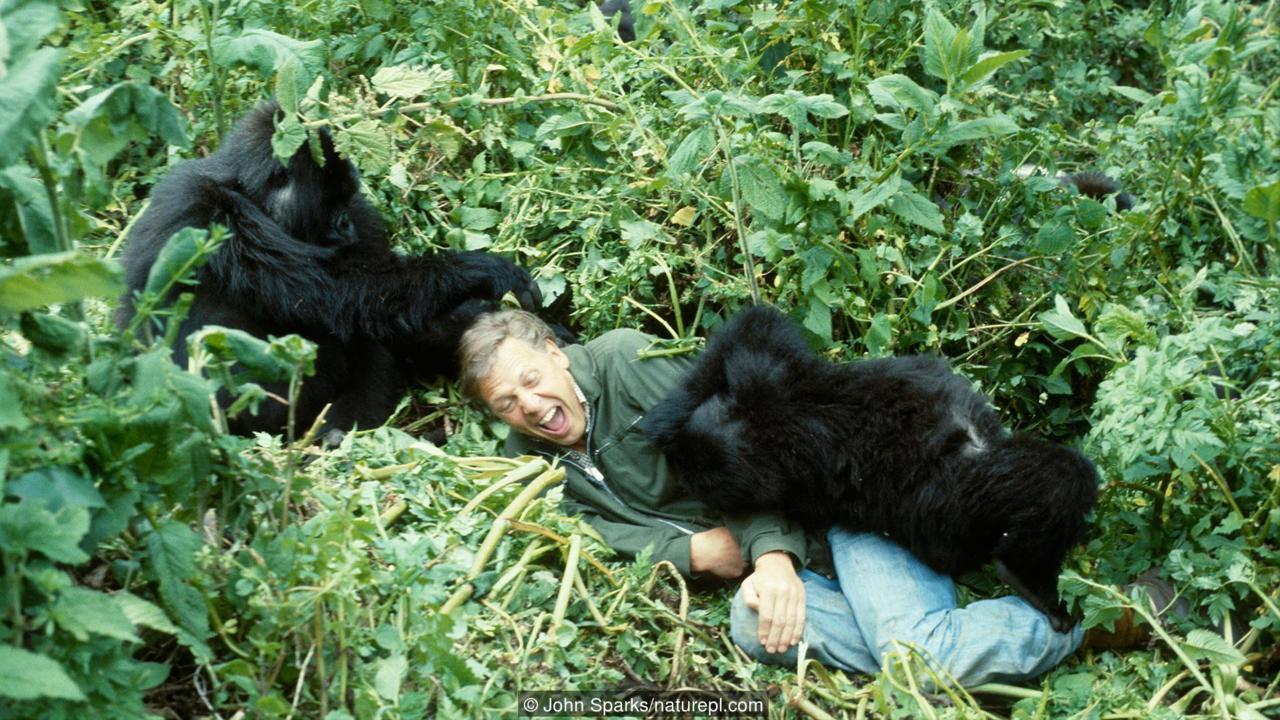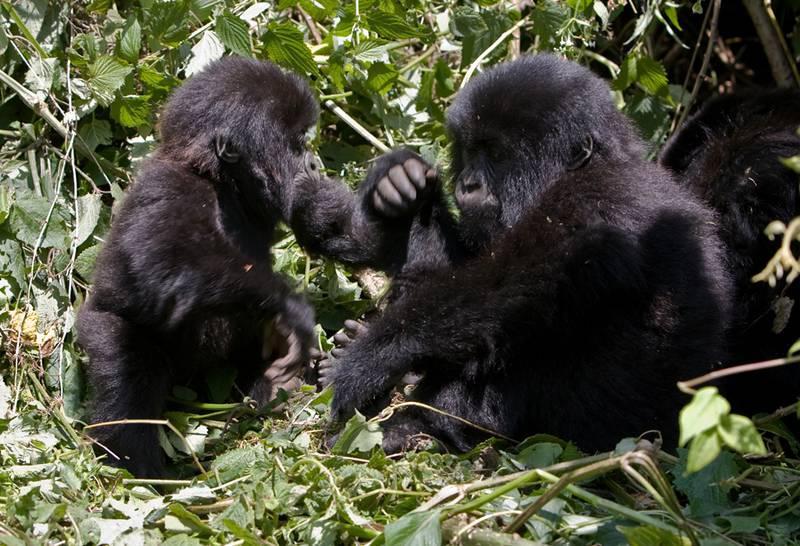The first image is the image on the left, the second image is the image on the right. Assess this claim about the two images: "A primate is holding a ball in one of the images.". Correct or not? Answer yes or no. No. The first image is the image on the left, the second image is the image on the right. Assess this claim about the two images: "A gorilla is holding onto something round and manmade, with a cross-shape on it.". Correct or not? Answer yes or no. No. 